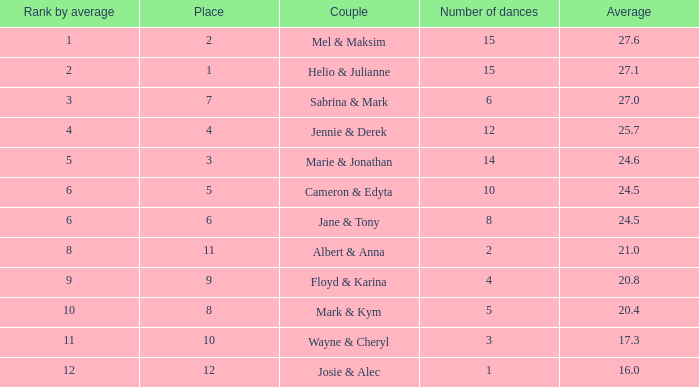What is the smallest place number when the total is 16 and average is less than 16? None. 